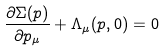<formula> <loc_0><loc_0><loc_500><loc_500>\frac { \partial \Sigma ( p ) } { \partial p _ { \mu } } + \Lambda _ { \mu } ( p , 0 ) = 0</formula> 